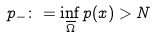Convert formula to latex. <formula><loc_0><loc_0><loc_500><loc_500>p _ { - } \colon = \inf _ { \overline { \Omega } } p ( x ) > N</formula> 